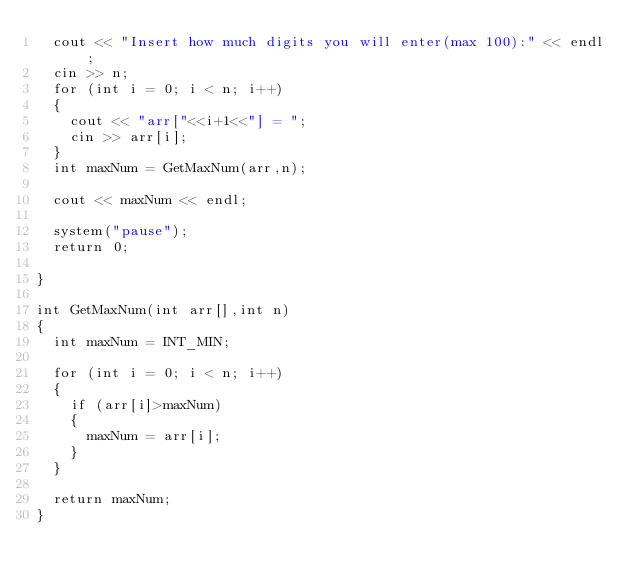<code> <loc_0><loc_0><loc_500><loc_500><_C++_>	cout << "Insert how much digits you will enter(max 100):" << endl;
	cin >> n;
	for (int i = 0; i < n; i++)
	{
		cout << "arr["<<i+1<<"] = ";
		cin >> arr[i];
	}
	int maxNum = GetMaxNum(arr,n);

	cout << maxNum << endl;

	system("pause");
	return 0;

}

int GetMaxNum(int arr[],int n)
{
	int maxNum = INT_MIN;

	for (int i = 0; i < n; i++)
	{
		if (arr[i]>maxNum)
		{
			maxNum = arr[i];
		}
	}

	return maxNum;
}</code> 